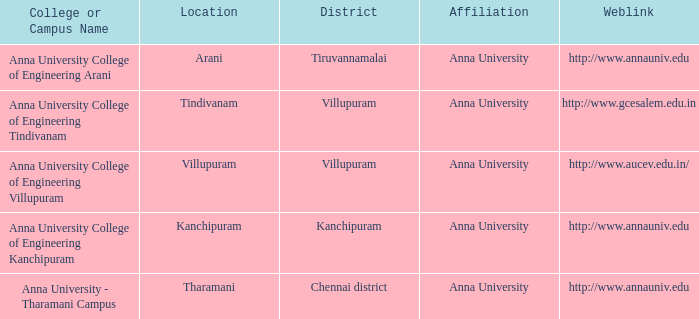What District has a Location of tharamani? Chennai district. 